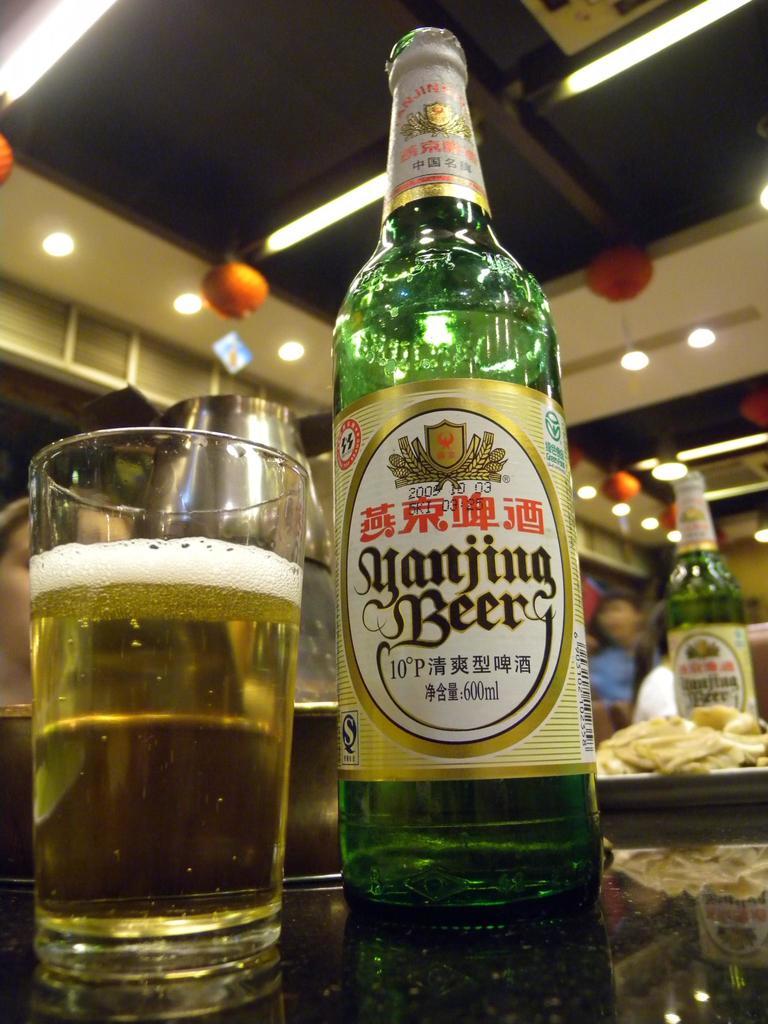Is this beer?
Give a very brief answer. Yes. What is the name of this beer?
Give a very brief answer. Yanjing beer. 